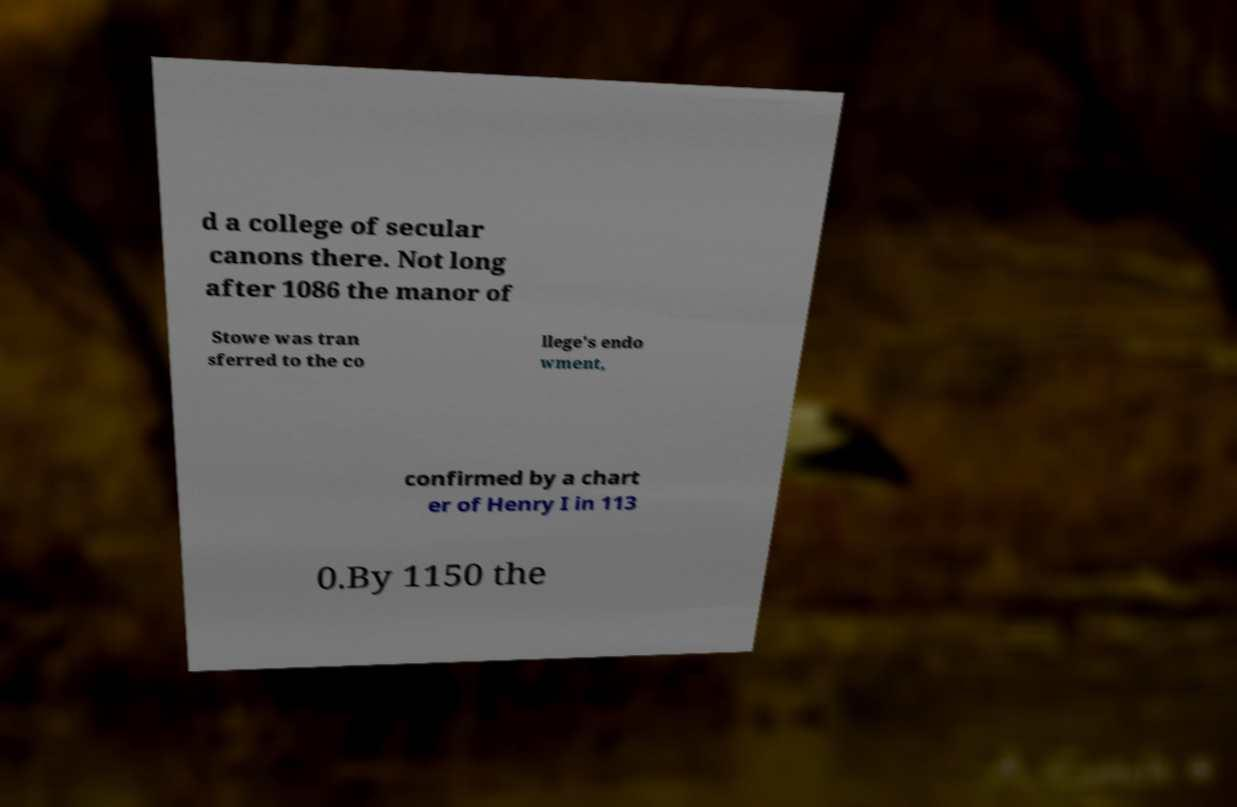Can you read and provide the text displayed in the image?This photo seems to have some interesting text. Can you extract and type it out for me? d a college of secular canons there. Not long after 1086 the manor of Stowe was tran sferred to the co llege's endo wment, confirmed by a chart er of Henry I in 113 0.By 1150 the 